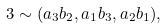<formula> <loc_0><loc_0><loc_500><loc_500>3 \sim ( a _ { 3 } b _ { 2 } , a _ { 1 } b _ { 3 } , a _ { 2 } b _ { 1 } ) ,</formula> 